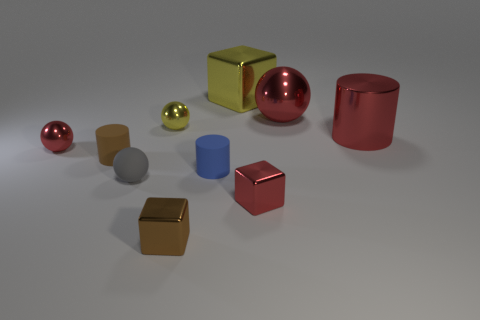Subtract all gray cubes. How many red spheres are left? 2 Subtract all small cylinders. How many cylinders are left? 1 Subtract all gray spheres. How many spheres are left? 3 Subtract all gray spheres. Subtract all red blocks. How many spheres are left? 3 Subtract all spheres. How many objects are left? 6 Add 3 shiny objects. How many shiny objects are left? 10 Add 3 tiny brown metal objects. How many tiny brown metal objects exist? 4 Subtract 1 blue cylinders. How many objects are left? 9 Subtract all small brown rubber cylinders. Subtract all small blue matte blocks. How many objects are left? 9 